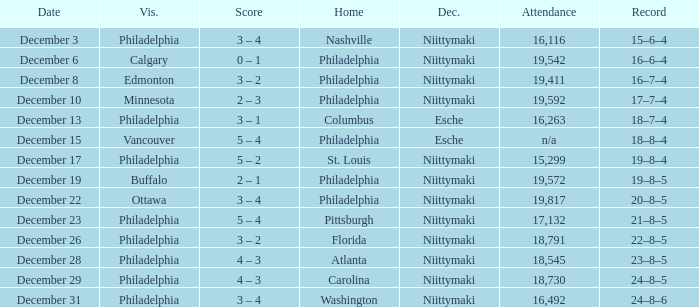What was the score when the attendance was 18,545? 4 – 3. 